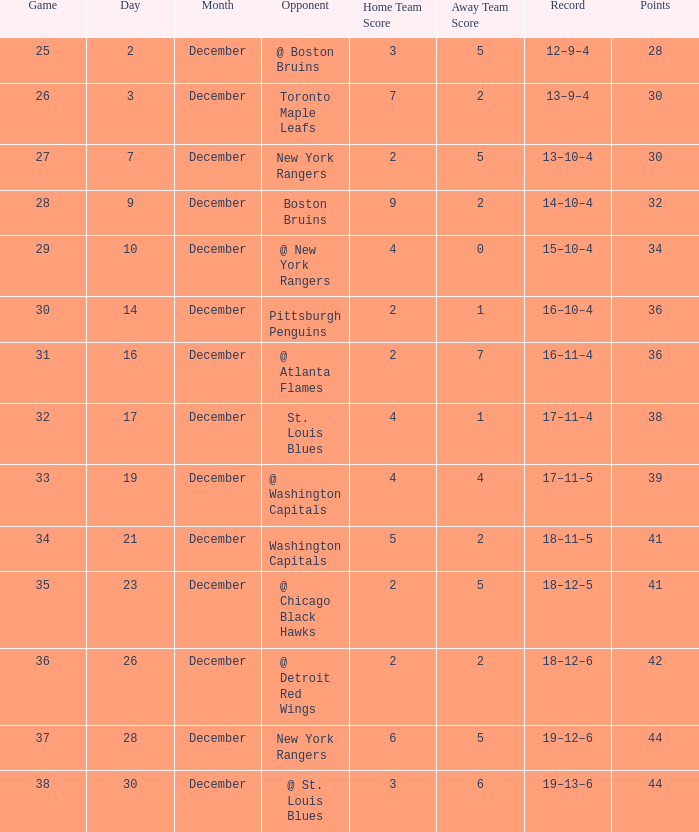Which Game has a Score of 4–1? 32.0. 